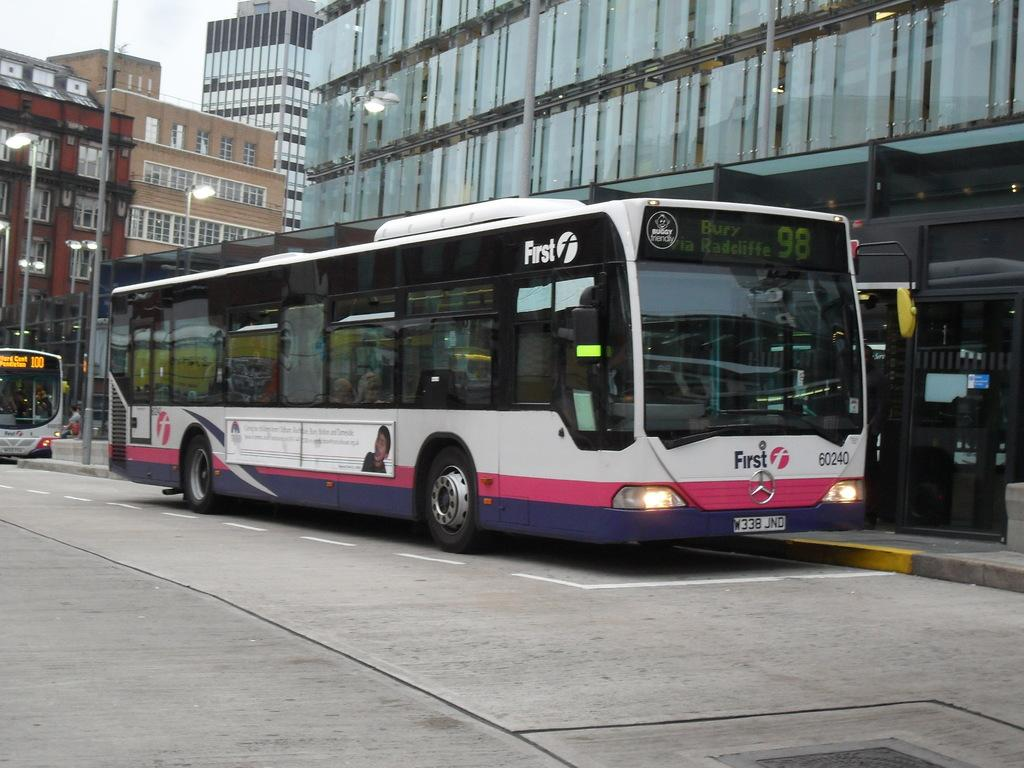<image>
Give a short and clear explanation of the subsequent image. The bus shown is travelling to Bury and is number 98. 